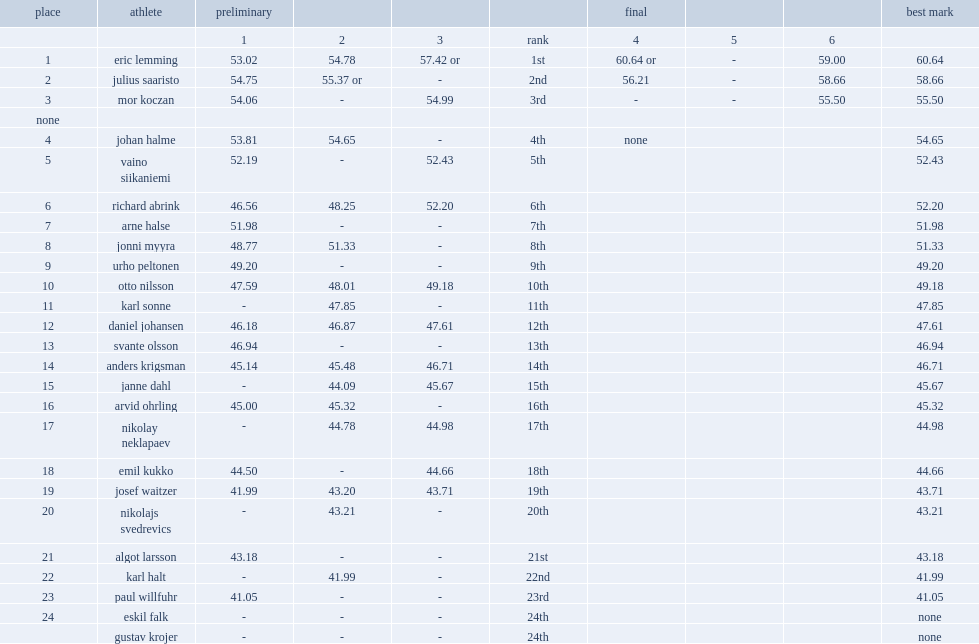What was the result that lemming got at the final as the record in the 1912 summer olympics? 60.64 or. 